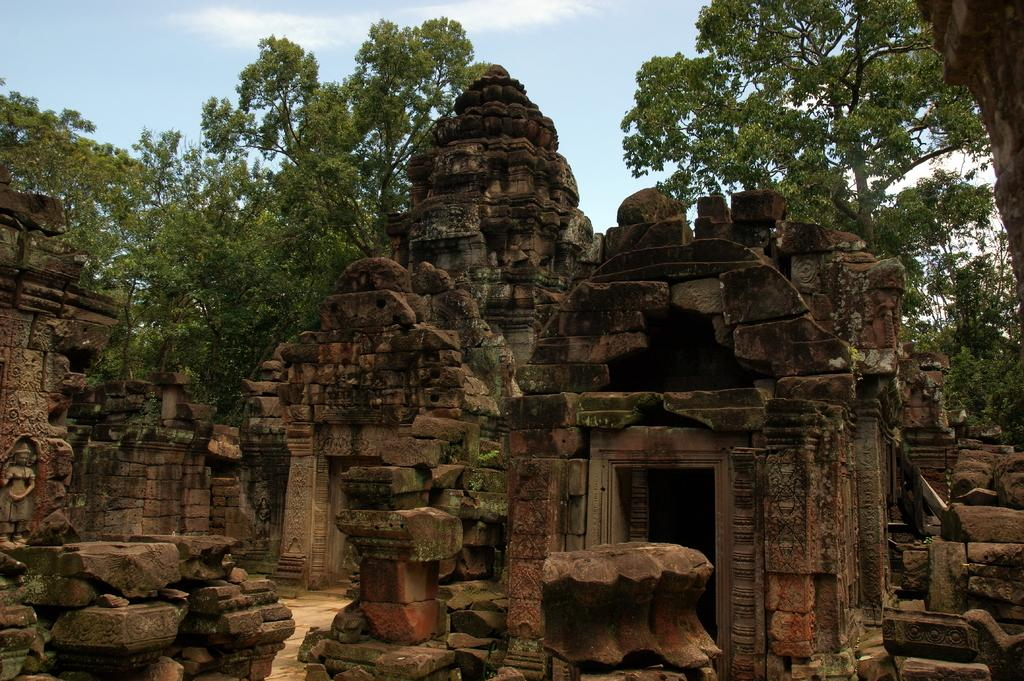What type of structures are made up of rocks in the image? There are temples made up of rocks in the image. What is located to the left of the temples? There is a statue to the left of the temples. What can be seen in the background of the image? There are many trees and the sky visible in the background of the image. What type of joke is being told by the statue in the image? There is no indication in the image that the statue is telling a joke, as statues are not capable of speech or humor. 